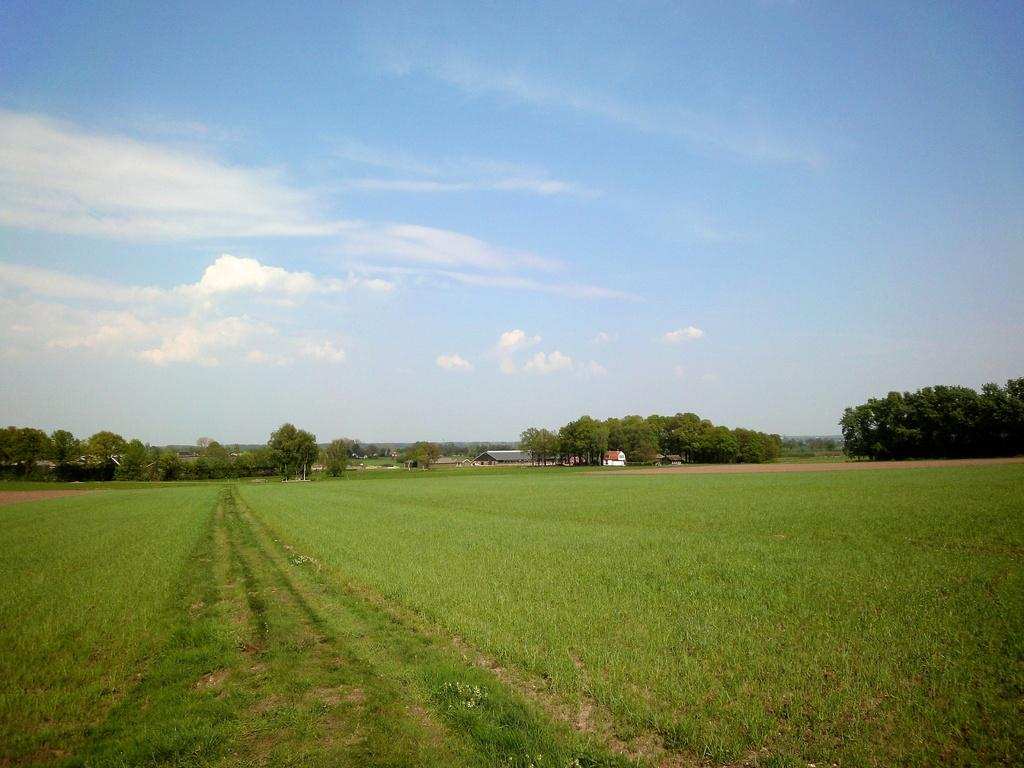What type of vegetation is on the ground in the image? There is grass on the ground in the image. What can be seen in the background of the image? There are trees and the sky visible in the background of the image. What is the condition of the sky in the image? The sky is visible in the background of the image, and there are clouds present. Where is the father standing in the image? There is no father present in the image. What type of pest can be seen crawling on the grass in the image? There are no pests visible in the image; it only features grass, trees, and the sky. 